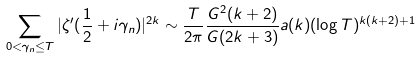<formula> <loc_0><loc_0><loc_500><loc_500>\sum _ { 0 < \gamma _ { n } \leq T } | \zeta ^ { \prime } ( \frac { 1 } { 2 } + i \gamma _ { n } ) | ^ { 2 k } \sim \frac { T } { 2 \pi } \frac { G ^ { 2 } ( k + 2 ) } { G ( 2 k + 3 ) } a ( k ) ( \log T ) ^ { k ( k + 2 ) + 1 }</formula> 